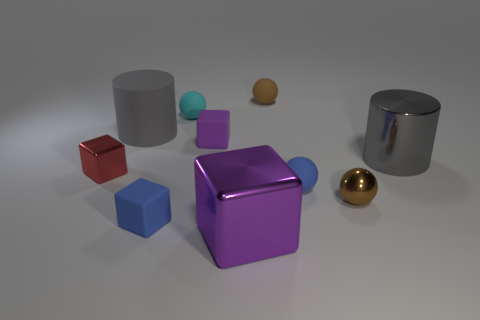Is there anything else that has the same size as the shiny cylinder?
Provide a short and direct response. Yes. There is a small blue object that is the same shape as the red thing; what is its material?
Give a very brief answer. Rubber. There is a small blue matte thing on the right side of the brown sphere behind the purple matte block; is there a purple matte object left of it?
Provide a succinct answer. Yes. Does the brown object in front of the large gray rubber thing have the same shape as the metallic thing that is left of the tiny purple rubber thing?
Your response must be concise. No. Are there more cyan matte objects in front of the purple shiny cube than big shiny cylinders?
Ensure brevity in your answer.  No. How many things are cyan metallic objects or small shiny things?
Provide a short and direct response. 2. What is the color of the tiny metal ball?
Provide a succinct answer. Brown. How many other objects are the same color as the large cube?
Give a very brief answer. 1. Are there any large gray rubber things behind the cyan matte ball?
Your answer should be very brief. No. What is the color of the small object that is left of the big cylinder behind the big gray cylinder to the right of the large rubber cylinder?
Your answer should be very brief. Red. 